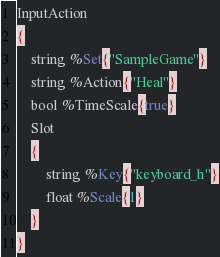Convert code to text. <code><loc_0><loc_0><loc_500><loc_500><_SQL_>InputAction
{
	string %Set{"SampleGame"}
	string %Action{"Heal"}
	bool %TimeScale{true}
	Slot
	{
		string %Key{"keyboard_h"}
		float %Scale{1}
	}
}
</code> 